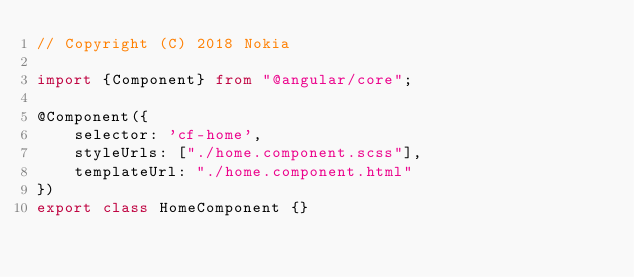Convert code to text. <code><loc_0><loc_0><loc_500><loc_500><_TypeScript_>// Copyright (C) 2018 Nokia

import {Component} from "@angular/core";

@Component({
    selector: 'cf-home',
    styleUrls: ["./home.component.scss"],
    templateUrl: "./home.component.html"
})
export class HomeComponent {}
</code> 